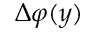<formula> <loc_0><loc_0><loc_500><loc_500>\Delta \varphi ( y )</formula> 